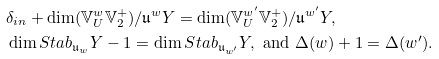<formula> <loc_0><loc_0><loc_500><loc_500>& \delta _ { i n } + \dim ( \mathbb { V } _ { U } ^ { w } \mathbb { V } ^ { + } _ { 2 } ) / \mathfrak u ^ { w } Y = \dim ( \mathbb { V } _ { U } ^ { w ^ { \prime } } \mathbb { V } ^ { + } _ { 2 } ) / \mathfrak u ^ { w ^ { \prime } } Y , \\ & \dim S t a b _ { \mathfrak u _ { w } } Y - 1 = \dim S t a b _ { \mathfrak u _ { w ^ { \prime } } } Y , \text { and } \Delta ( w ) + 1 = \Delta ( w ^ { \prime } ) .</formula> 